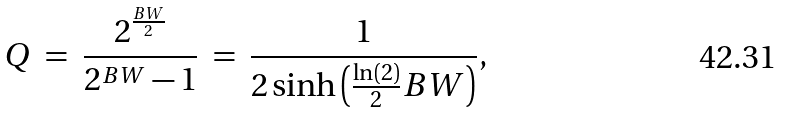<formula> <loc_0><loc_0><loc_500><loc_500>Q \ = \ { \frac { 2 ^ { \frac { B W } { 2 } } } { 2 ^ { B W } - 1 } } \ = \ { \frac { 1 } { 2 \sinh \left ( { \frac { \ln ( 2 ) } { 2 } } B W \right ) } } ,</formula> 